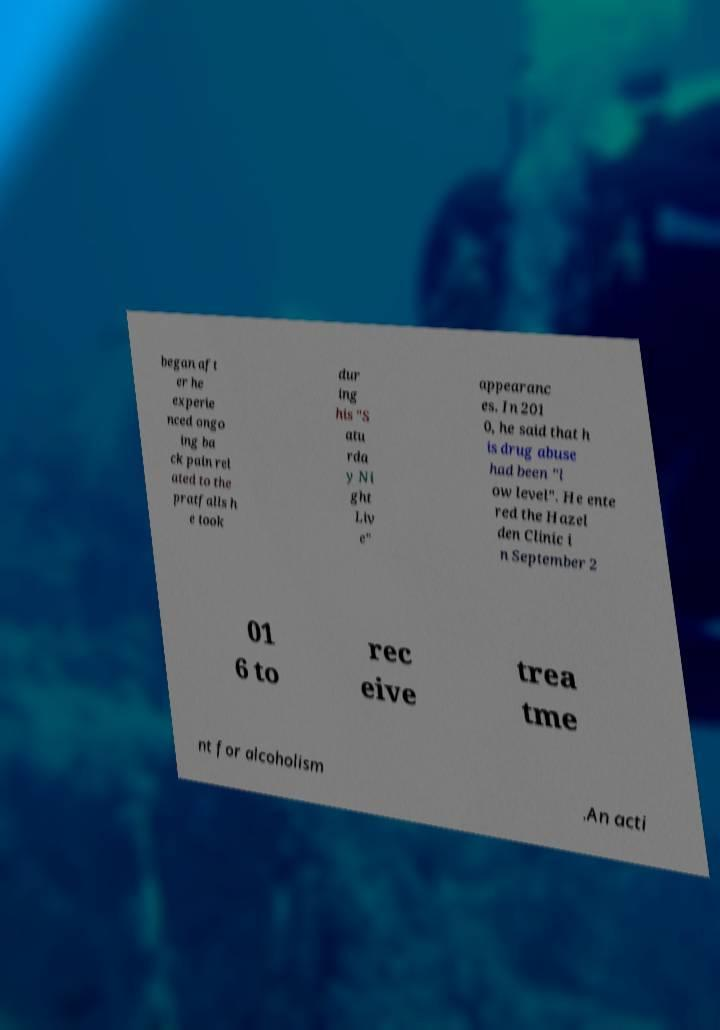Can you accurately transcribe the text from the provided image for me? began aft er he experie nced ongo ing ba ck pain rel ated to the pratfalls h e took dur ing his "S atu rda y Ni ght Liv e" appearanc es. In 201 0, he said that h is drug abuse had been "l ow level". He ente red the Hazel den Clinic i n September 2 01 6 to rec eive trea tme nt for alcoholism .An acti 